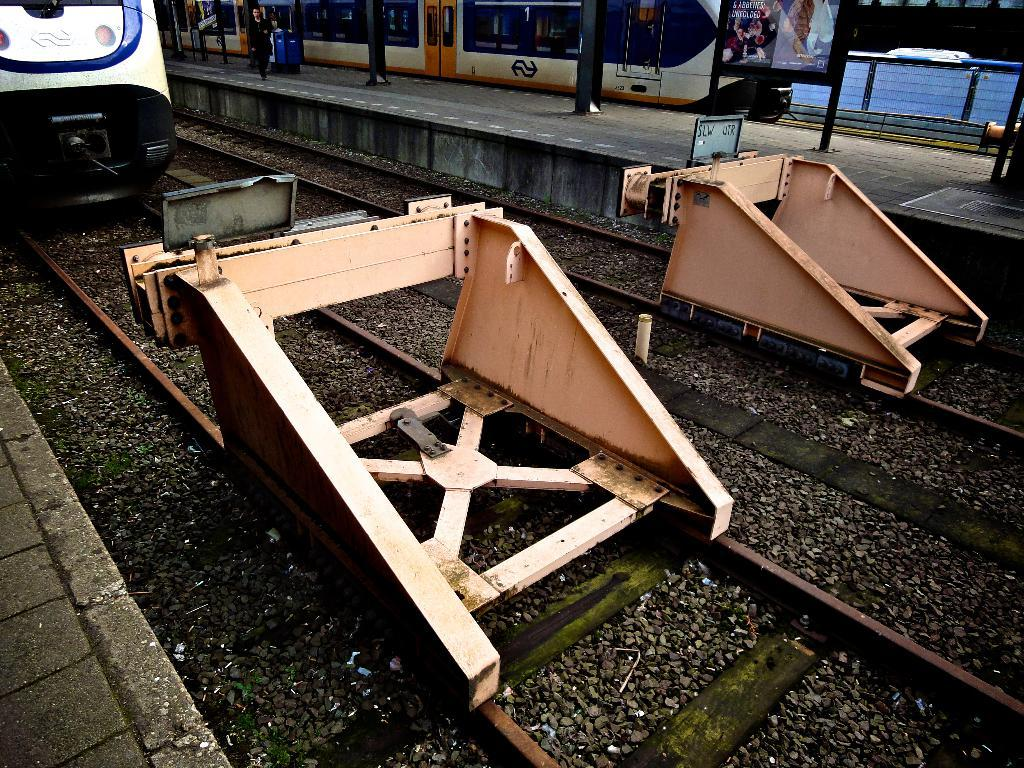What type of vehicles can be seen in the image? There are trains in the image. What material is used for the train tracks? Metal rods are present on the train tracks. What is the person near the train doing? A person is walking beside the train. What type of barrier is present in the image? There is a fence in the image. What type of advertisement or signage is visible in the image? A hoarding is visible in the image. Can you see the person's toe in the image? There is no indication of the person's toe in the image; only their presence beside the train is mentioned. 